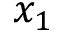Convert formula to latex. <formula><loc_0><loc_0><loc_500><loc_500>x _ { 1 }</formula> 